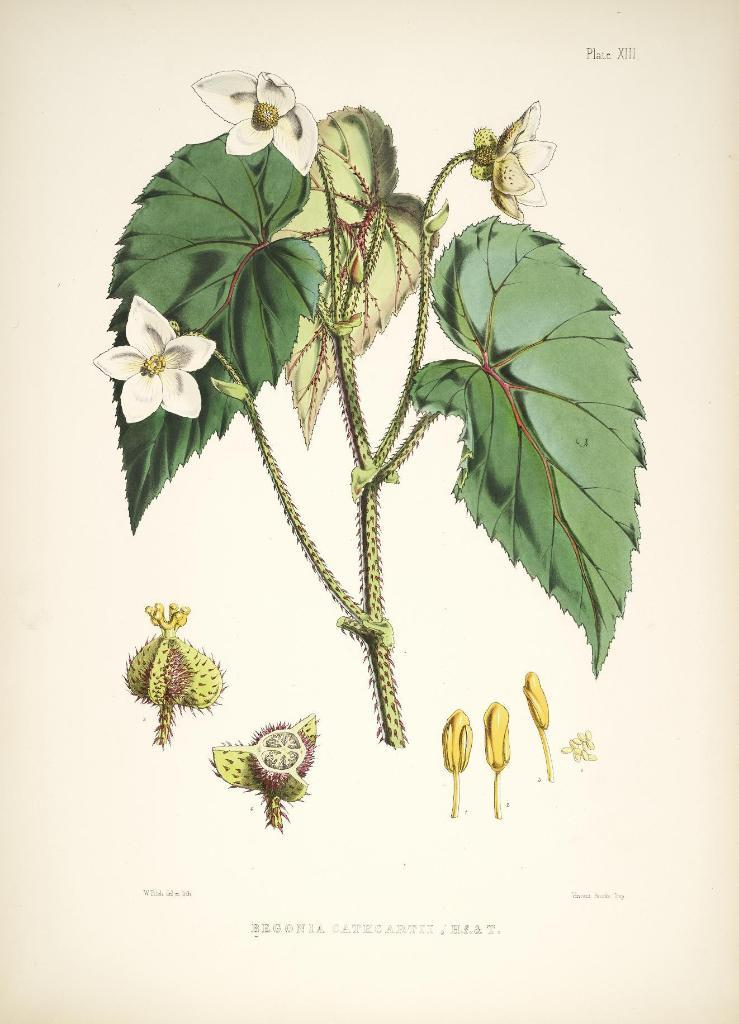What type of plant is featured in the image? There is a flower in the image. What other parts of the plant can be seen in the image? There are leaves in the image. Can you describe any specific features of the flower? Parts of a flower are visible in the image. How many men can be seen interacting with the flower in the image? There are no men present in the image; it features a flower and leaves. What type of trees are visible in the image? There are no trees visible in the image; it features a flower and leaves. 